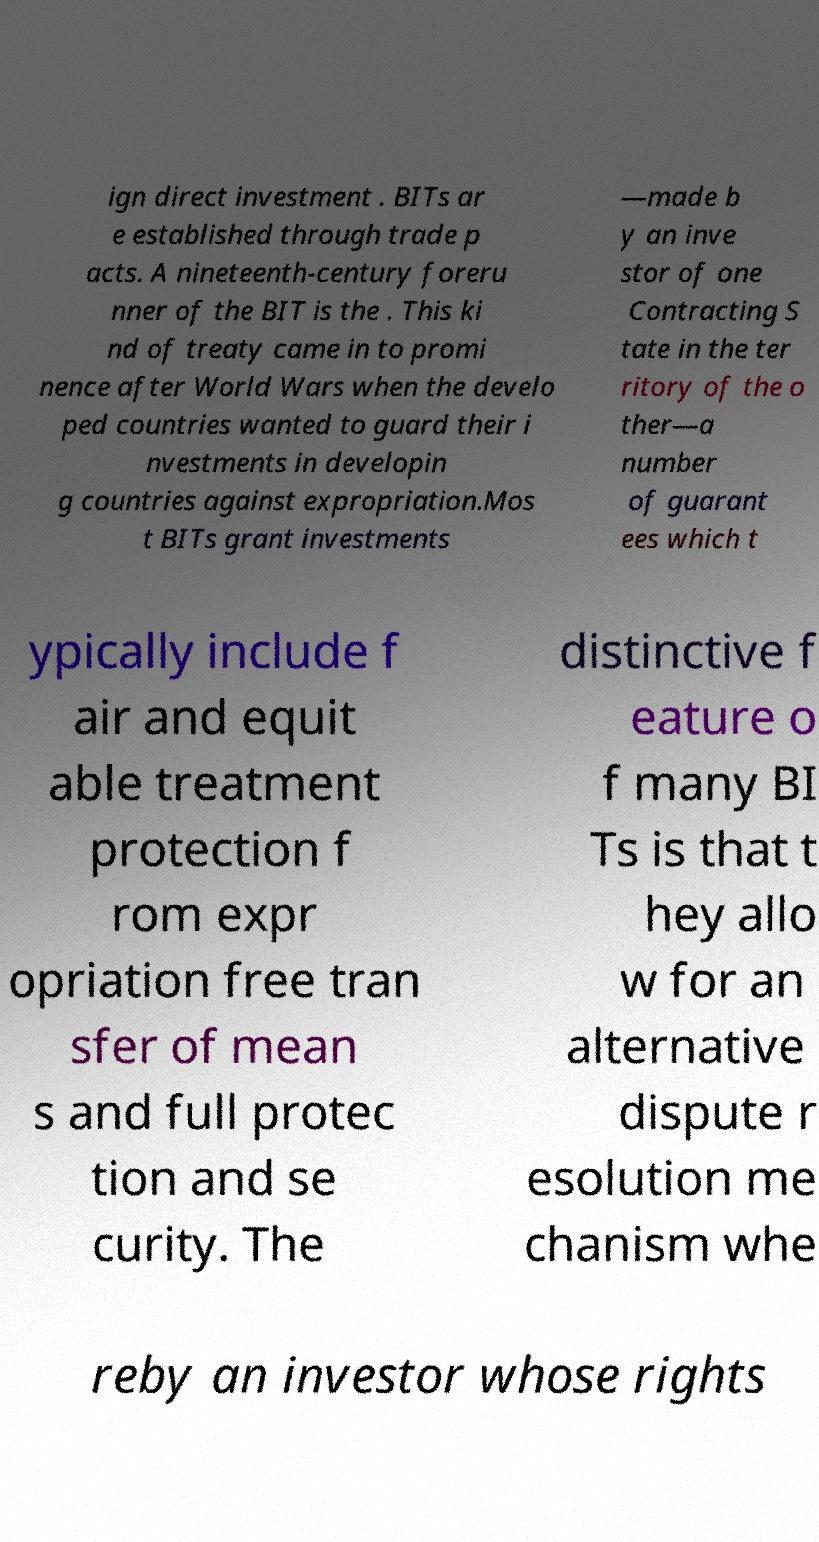Please read and relay the text visible in this image. What does it say? ign direct investment . BITs ar e established through trade p acts. A nineteenth-century foreru nner of the BIT is the . This ki nd of treaty came in to promi nence after World Wars when the develo ped countries wanted to guard their i nvestments in developin g countries against expropriation.Mos t BITs grant investments —made b y an inve stor of one Contracting S tate in the ter ritory of the o ther—a number of guarant ees which t ypically include f air and equit able treatment protection f rom expr opriation free tran sfer of mean s and full protec tion and se curity. The distinctive f eature o f many BI Ts is that t hey allo w for an alternative dispute r esolution me chanism whe reby an investor whose rights 